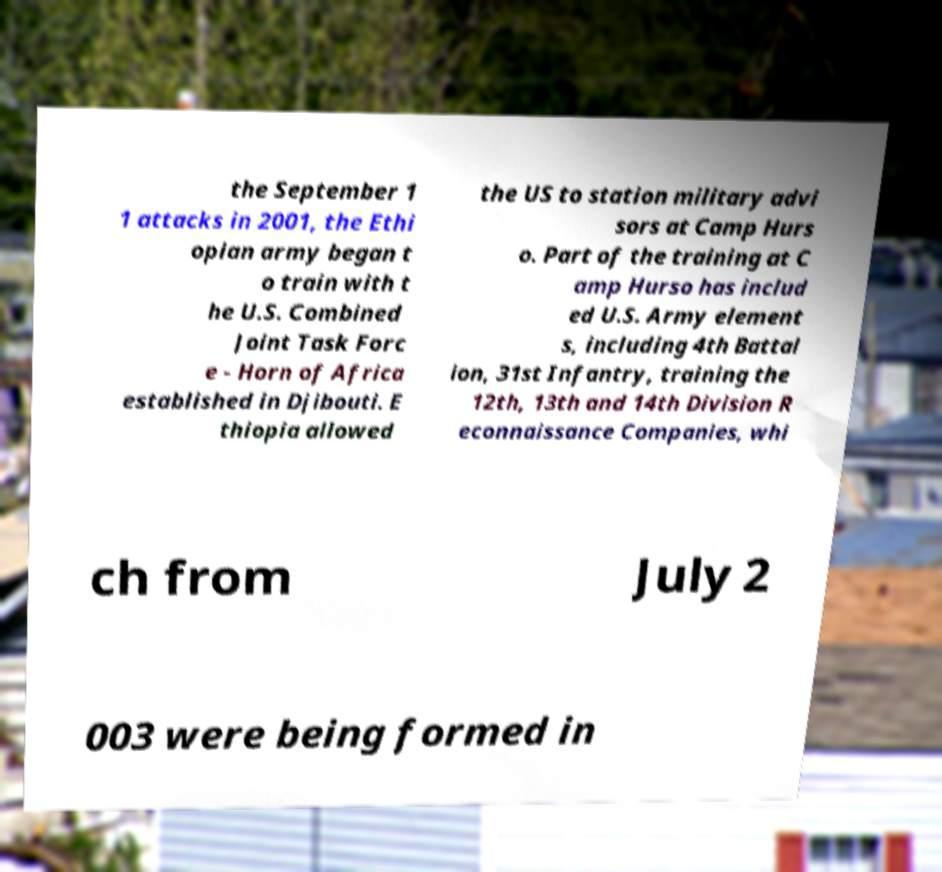I need the written content from this picture converted into text. Can you do that? the September 1 1 attacks in 2001, the Ethi opian army began t o train with t he U.S. Combined Joint Task Forc e - Horn of Africa established in Djibouti. E thiopia allowed the US to station military advi sors at Camp Hurs o. Part of the training at C amp Hurso has includ ed U.S. Army element s, including 4th Battal ion, 31st Infantry, training the 12th, 13th and 14th Division R econnaissance Companies, whi ch from July 2 003 were being formed in 